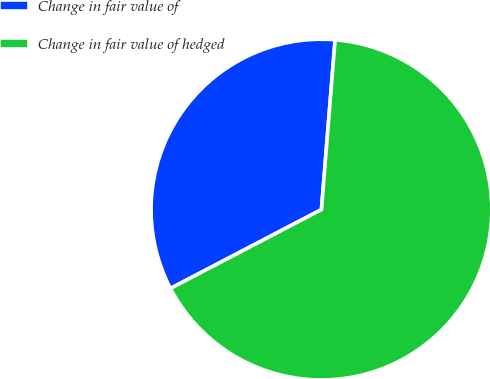<chart> <loc_0><loc_0><loc_500><loc_500><pie_chart><fcel>Change in fair value of<fcel>Change in fair value of hedged<nl><fcel>33.94%<fcel>66.06%<nl></chart> 